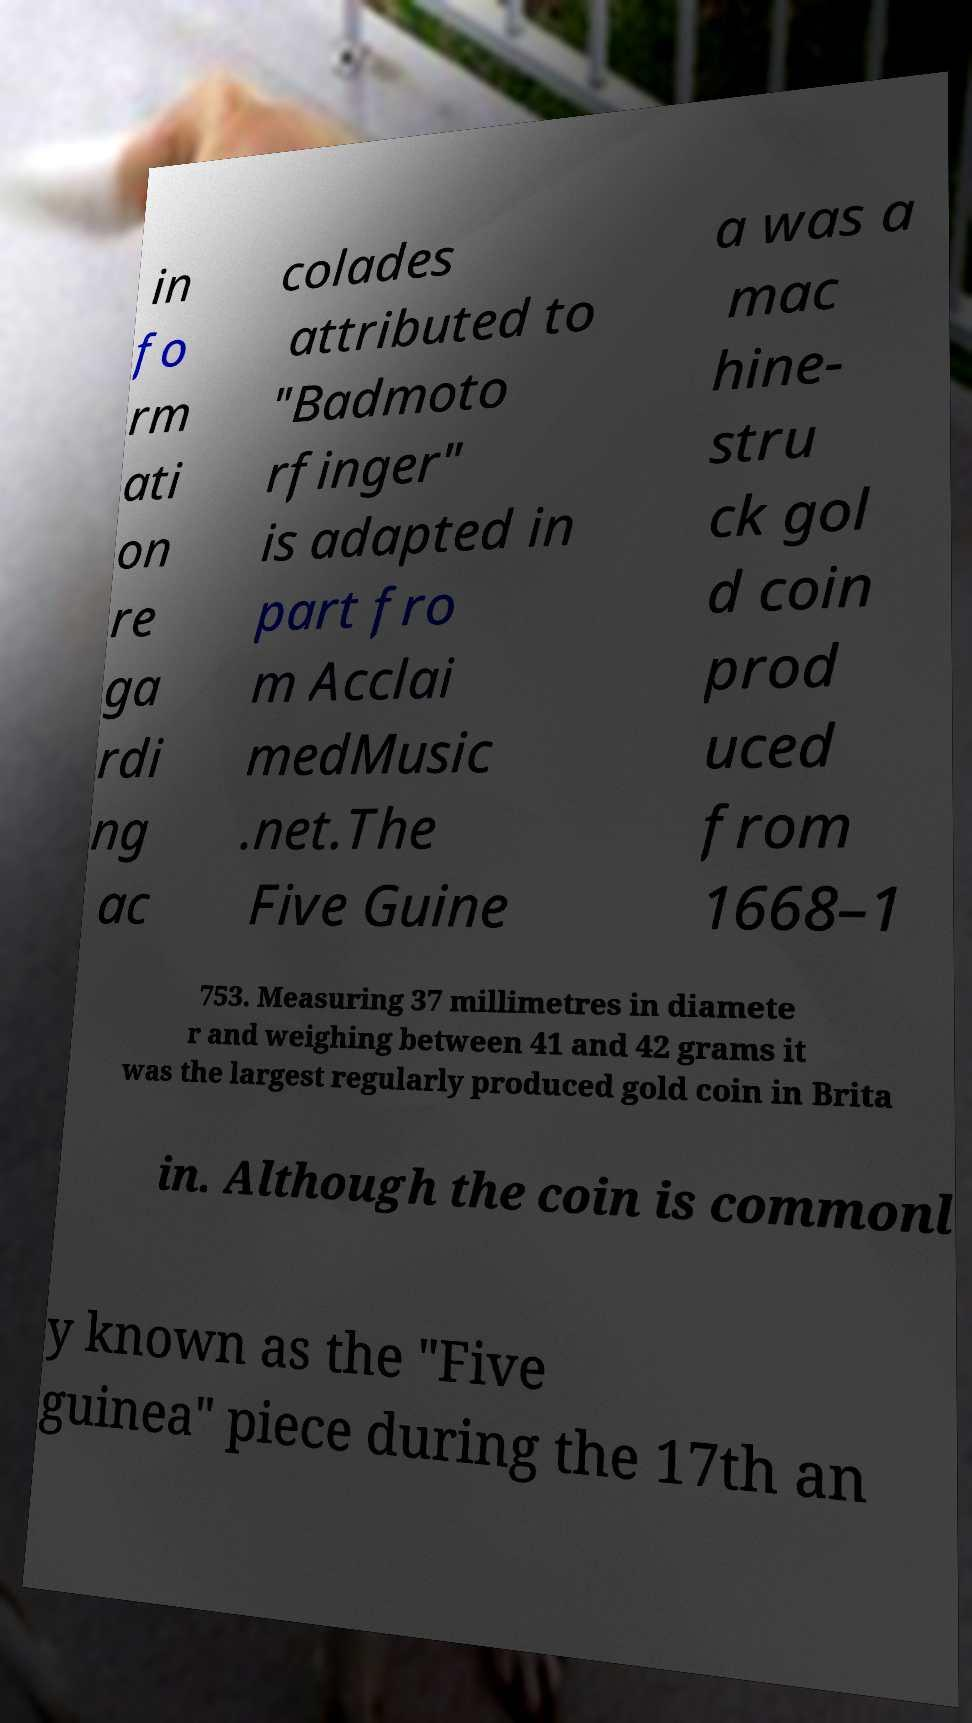Could you extract and type out the text from this image? in fo rm ati on re ga rdi ng ac colades attributed to "Badmoto rfinger" is adapted in part fro m Acclai medMusic .net.The Five Guine a was a mac hine- stru ck gol d coin prod uced from 1668–1 753. Measuring 37 millimetres in diamete r and weighing between 41 and 42 grams it was the largest regularly produced gold coin in Brita in. Although the coin is commonl y known as the "Five guinea" piece during the 17th an 